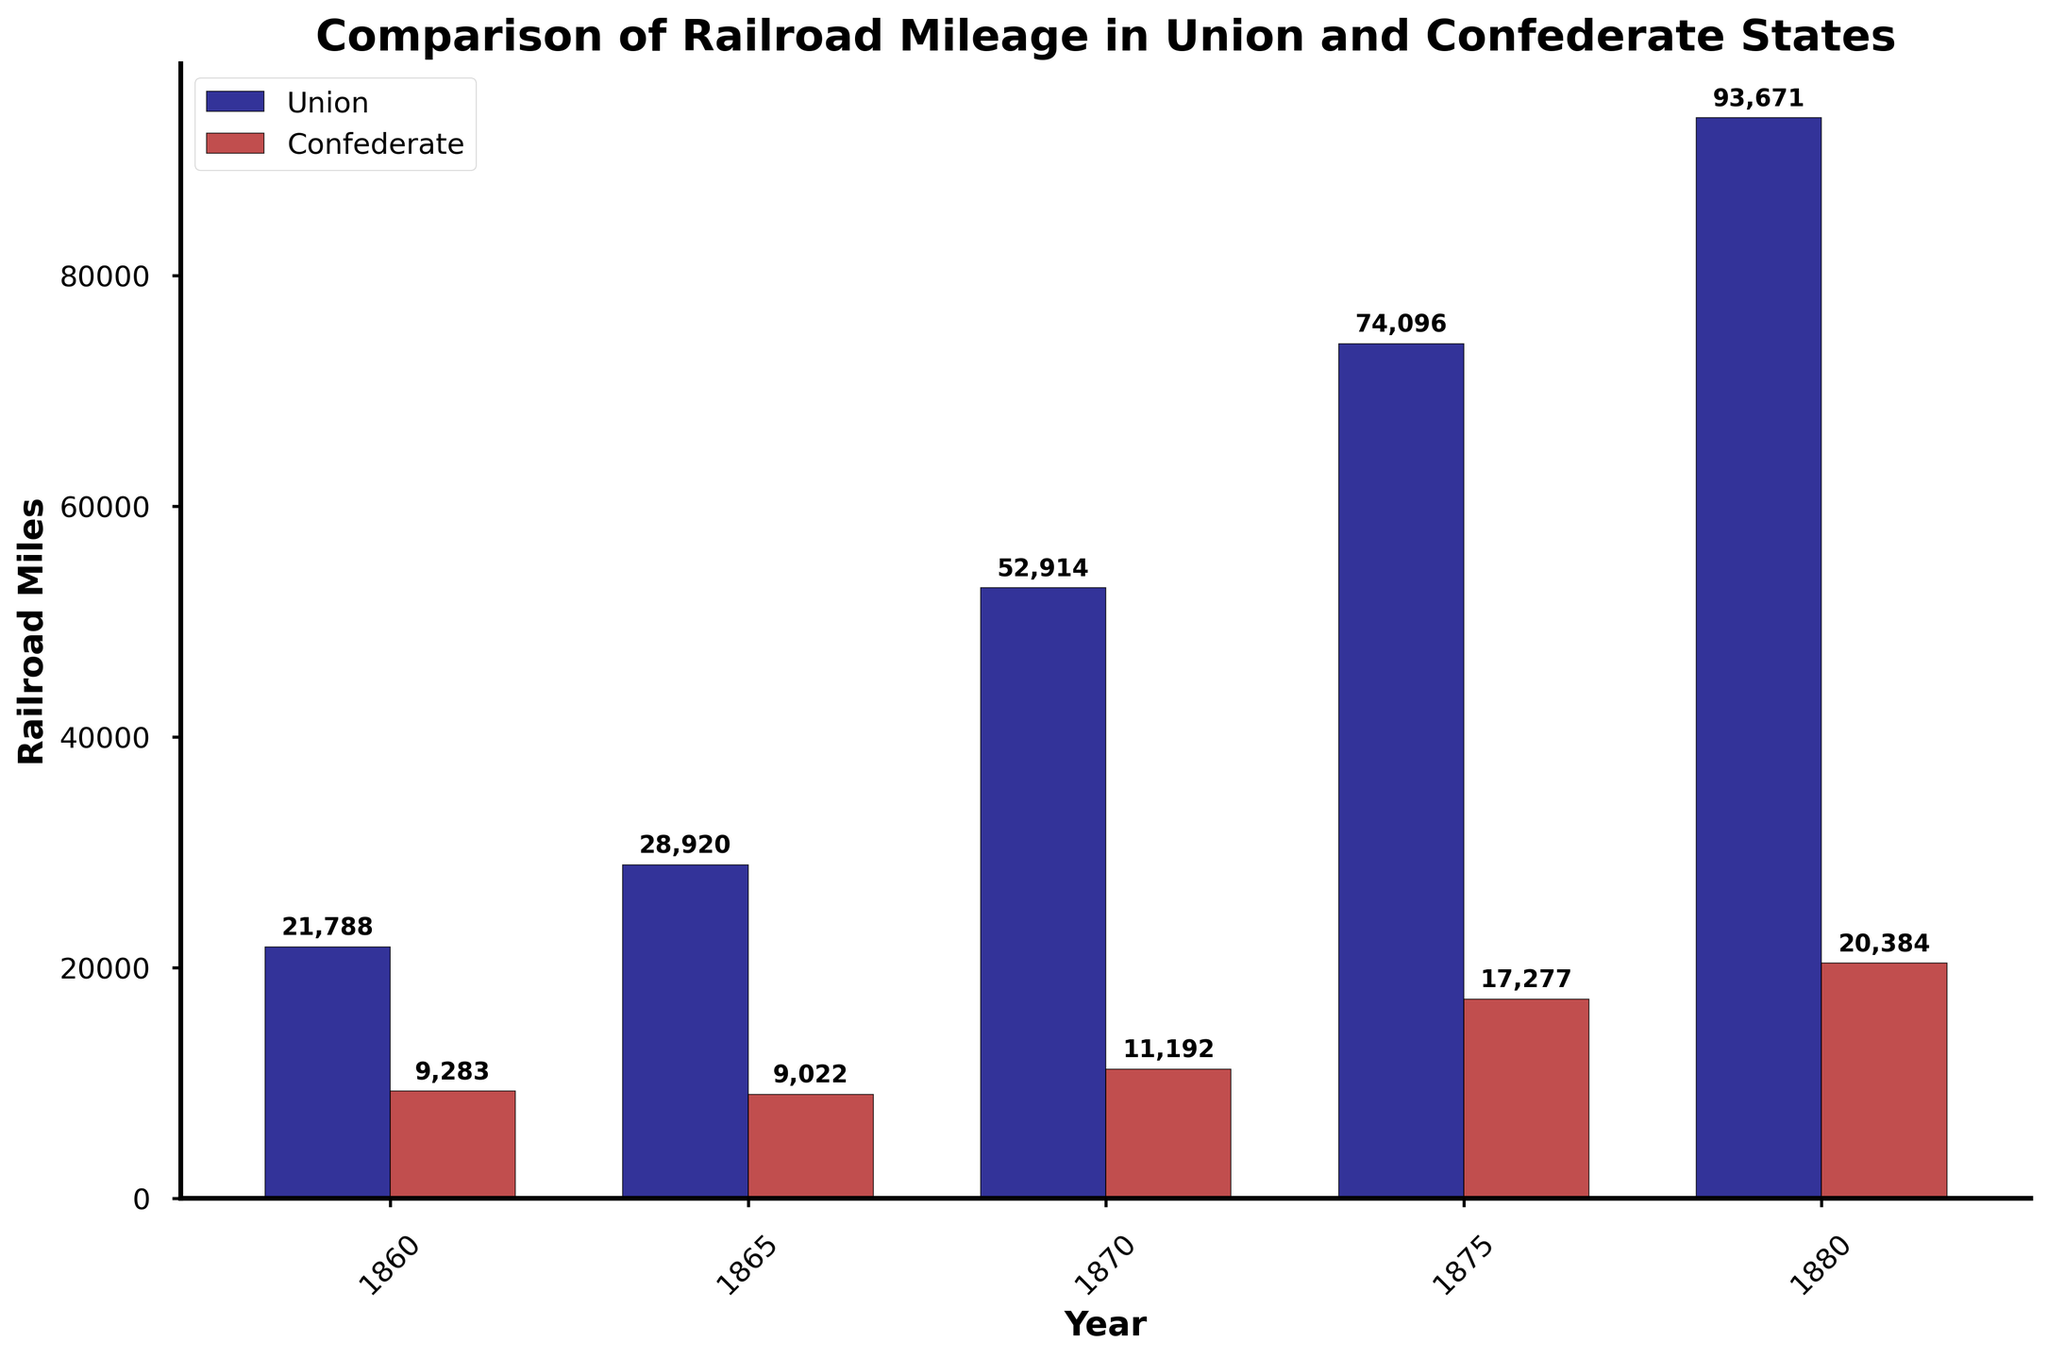What is the difference in Union railroad mileage between 1860 and 1870? To find the difference in railroad mileage, subtract the 1860 value from the 1870 value: 52,914 - 21,788 = 31,126 miles
Answer: 31,126 Which side had more railroad miles in 1880, and by how much? Compare the railroad miles of the Union and the Confederacy in 1880: Union had 93,671 miles and the Confederacy had 20,384 miles. The difference is 93,671 - 20,384 = 73,287 miles
Answer: Union, 73,287 What trend can be observed in the Union's railroad mileage from 1860 to 1880? Observing the bar heights for the Union from 1860 to 1880, there is a consistent increase in railroad mileage over each recorded year.
Answer: Increasing In which year did the Confederate states show the smallest difference in railroad mileage compared to the Union states? Calculate the differences for each year: 1860 (12,505 miles), 1865 (19,898 miles), 1870 (41,722 miles), 1875 (56,819 miles), 1880 (73,287 miles). The smallest difference is in 1860.
Answer: 1860 How did the Confederate railroad mileage change from 1865 to 1870? Subtract the mileage in 1865 from the mileage in 1870: 11,192 - 9,022 = 2,170 miles, which means it increased by 2,170 miles.
Answer: Increased by 2,170 Which side saw a greater absolute change in railroad mileage from 1875 to 1880? Calculate the change for both sides: Union mileage change from 74,096 to 93,671 = 19,575 miles, Confederate mileage change from 17,277 to 20,384 = 3,107 miles. The Union saw a greater change of 19,575 miles.
Answer: Union What does the color of the bars represent in the bar chart? The colors of the bars represent the two sides, with navy for the Union and firebrick for the Confederacy.
Answer: Navy represents Union, Firebrick represents Confederacy Between which two consecutive years did the Union experience the largest increase in railroad mileage? Calculate the year-over-year changes: 1860-1865 (7,132 miles), 1865-1870 (24,994 miles), 1870-1875 (21,182 miles), 1875-1880 (19,575 miles). The largest increase is between 1865 and 1870.
Answer: 1865 and 1870 What is the ratio of Union to Confederate railroad mileage in 1875? Divide the Union mileage by the Confederate mileage for 1875: 74,096 / 17,277 ≈ 4.29
Answer: Approximately 4.29 